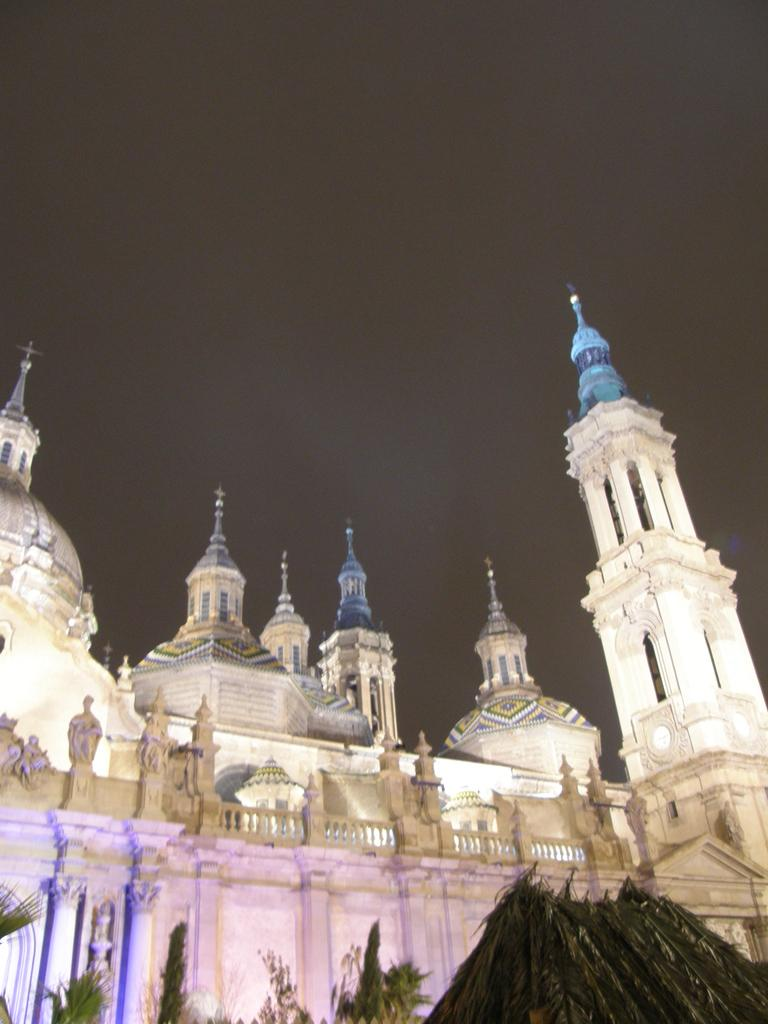What type of structure is present in the image? There is a building in the image. What is the color of the building? The building is white. What other elements can be seen in the image besides the building? There are trees in the image. What is the color of the sky in the image? The sky is black in the image. How does the building fold in the image? The building does not fold in the image; it is a solid structure. 